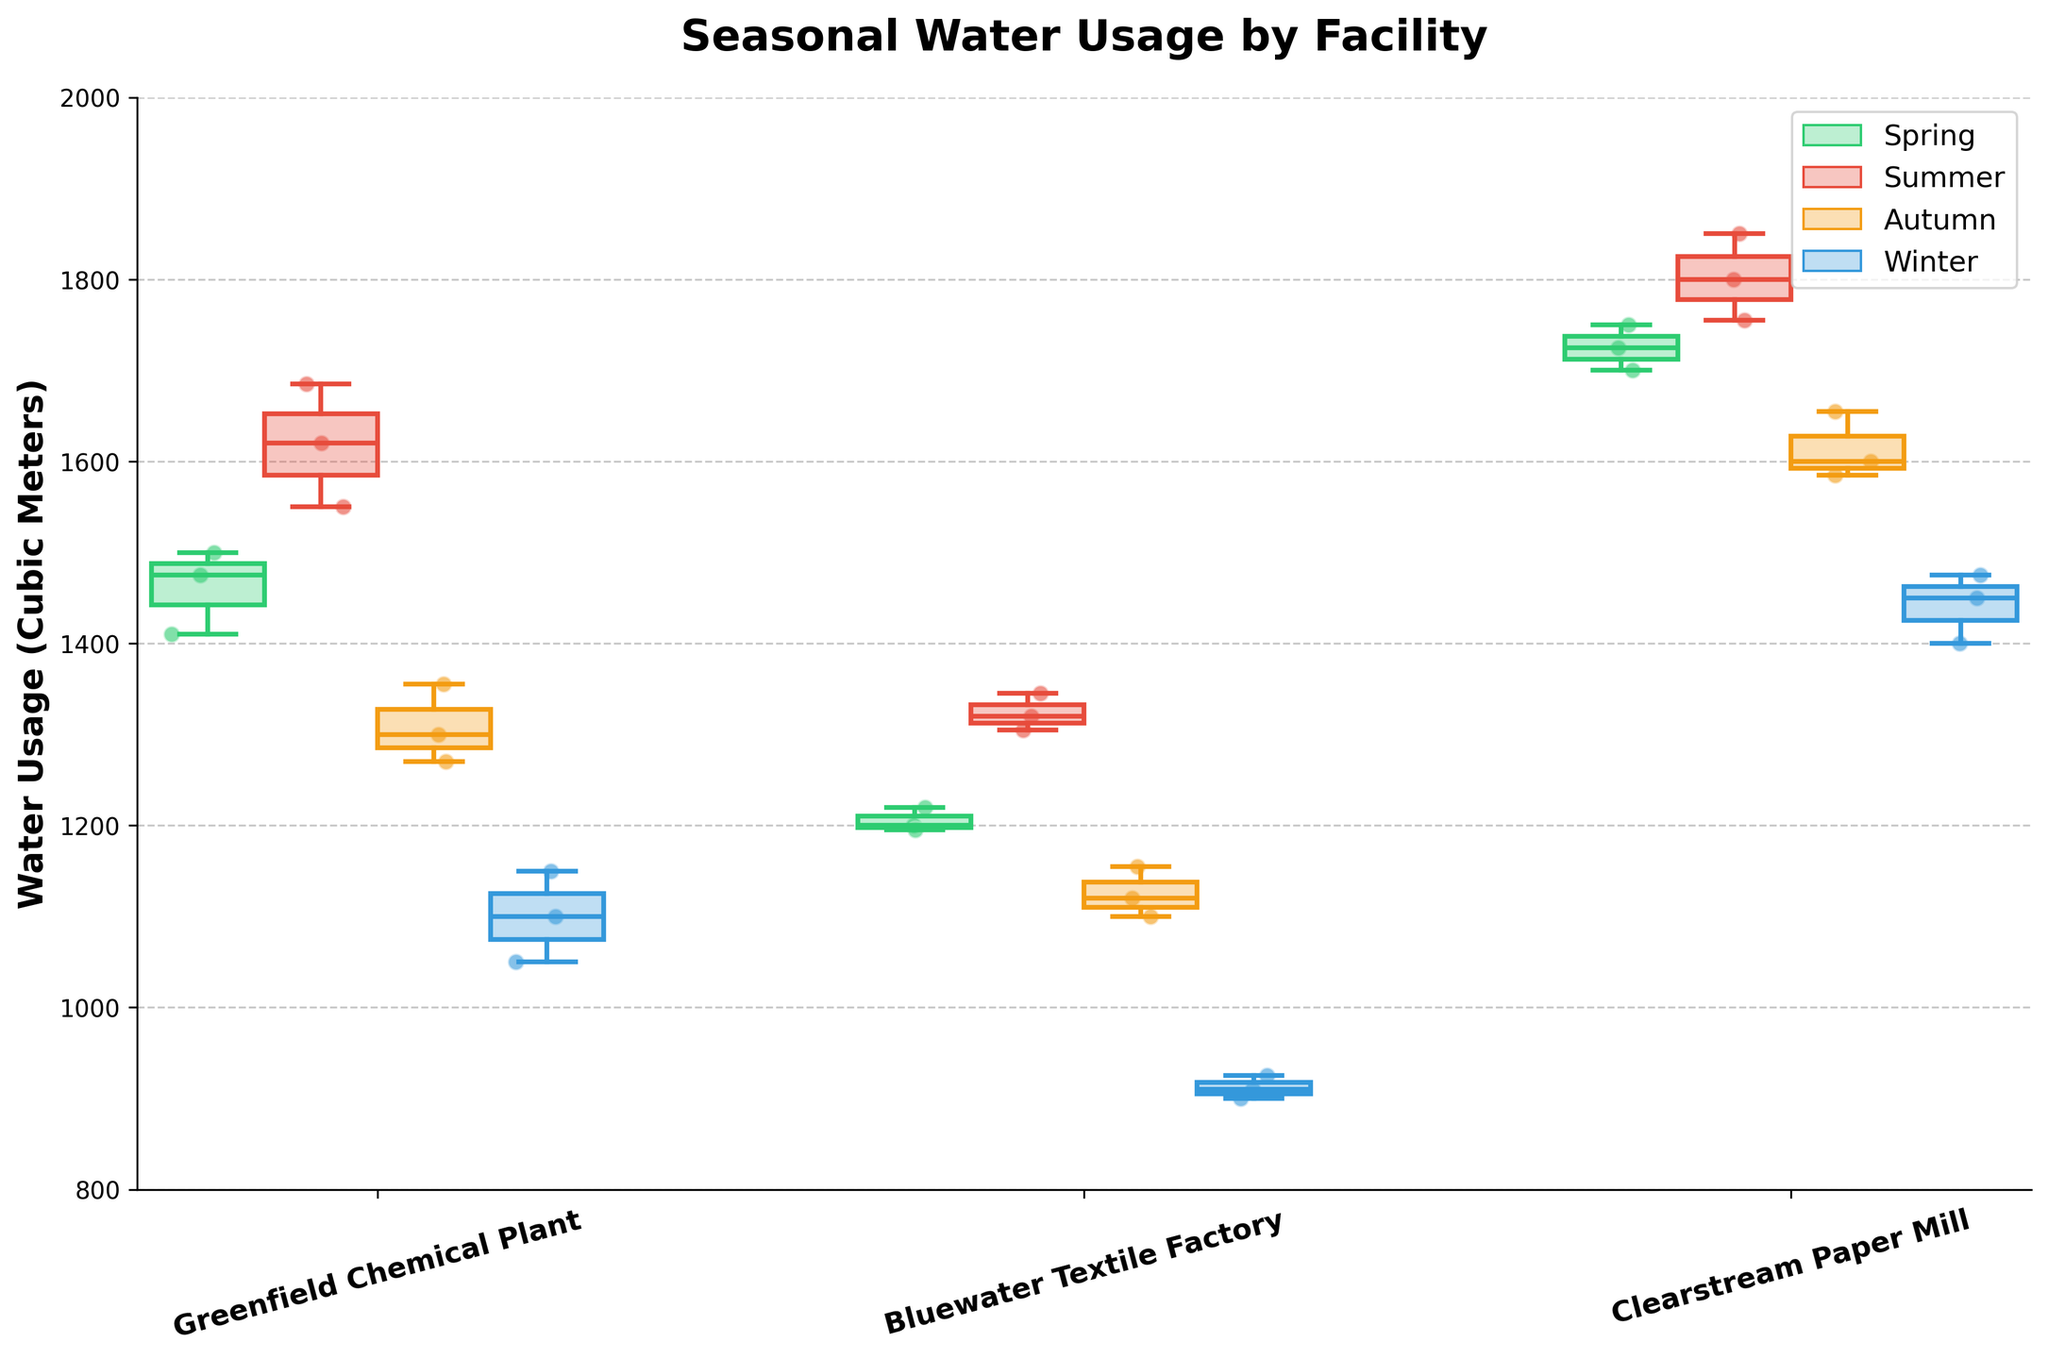What is the title of the plot? The title of the plot is usually at the top and summarizes what you're looking at. In this case, it would describe the content and focus of the plot.
Answer: Seasonal Water Usage by Facility How many facilities are represented in the plot? By counting the labels on the x-axis, we can determine the number of distinct facilities shown. Each unique label represents one facility.
Answer: Three What seasons are represented in the data? The legend or the color of the elements can be used to identify the different seasons included in the plot. The legend usually mentions the seasons explicitly.
Answer: Spring, Summer, Autumn, Winter Which facility has the highest median water usage in Summer? To find the highest median, look at the middle line in each of the summer box plots for all facilities and compare them. The facility with the highest line is the one with the highest median water usage.
Answer: Clearstream Paper Mill What is the general trend of water usage across seasons for the Greenfield Chemical Plant? To understand the trend, observe the box plots and scatter points for all seasons. Look at the median line position across seasons to see if water usage generally increases, decreases, or stays the same.
Answer: It decreases from Summer to Winter Which facility shows the lowest variation in water usage during Winter? Variation in a box plot is shown by the length of the box and the whiskers. The facility with the shortest box and whiskers indicates the lowest variation.
Answer: Greenfield Chemical Plant What is the most extreme outlier in the data presented? Outliers are typically shown as points outside the whiskers in box plots. The most extreme outlier would be the point furthest from the box. Identify the season and facility associated with this point.
Answer: Winter, Clearstream Paper Mill Compare the water usage in Spring between Bluewater Textile Factory and Greenfield Chemical Plant. Which one has the higher average usage? To find the average, sum the scatter points' values for each facility in Spring and then divide by the number of points. Compare the resulting averages.
Answer: Greenfield Chemical Plant What is the range of water usage in Summer for Bluewater Textile Factory? The range in a box plot is the distance between the max and min whiskers. For the Summer season, find the upper and lower whisker values and compute the difference.
Answer: 1345 - 1305 = 40 Is there a facility that shows a consistent decrease in water usage from Spring to Winter? To determine this, compare the median lines across seasons. If the median consistently drops from Spring to Winter for a facility, it shows a consistent decrease.
Answer: Bluewater Textile Factory 